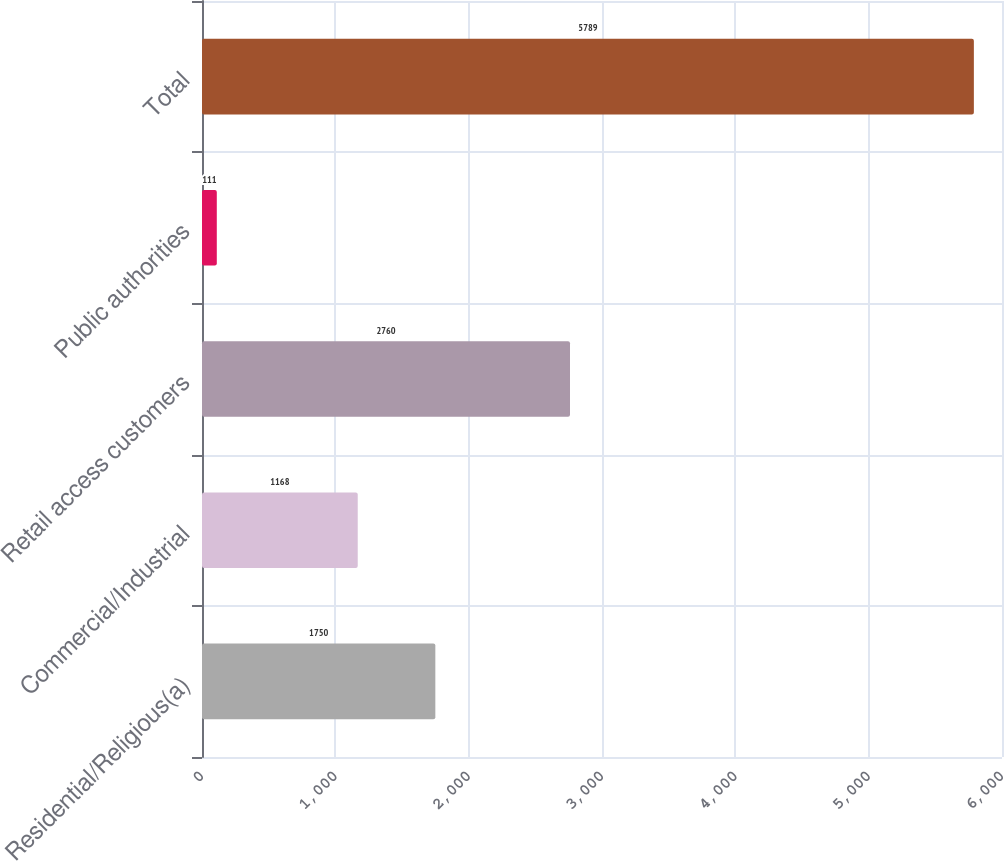<chart> <loc_0><loc_0><loc_500><loc_500><bar_chart><fcel>Residential/Religious(a)<fcel>Commercial/Industrial<fcel>Retail access customers<fcel>Public authorities<fcel>Total<nl><fcel>1750<fcel>1168<fcel>2760<fcel>111<fcel>5789<nl></chart> 